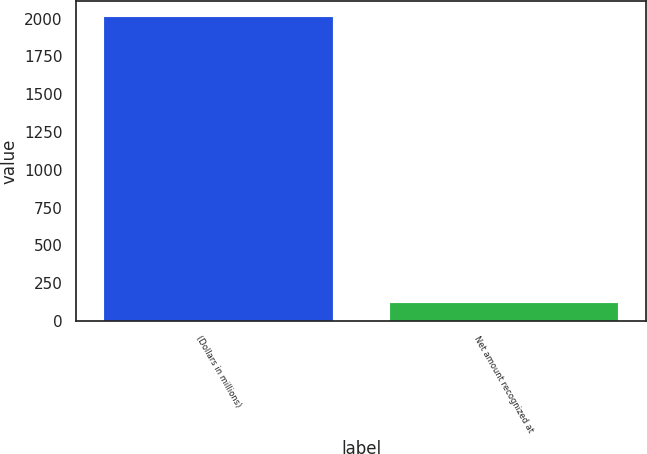<chart> <loc_0><loc_0><loc_500><loc_500><bar_chart><fcel>(Dollars in millions)<fcel>Net amount recognized at<nl><fcel>2013<fcel>123<nl></chart> 